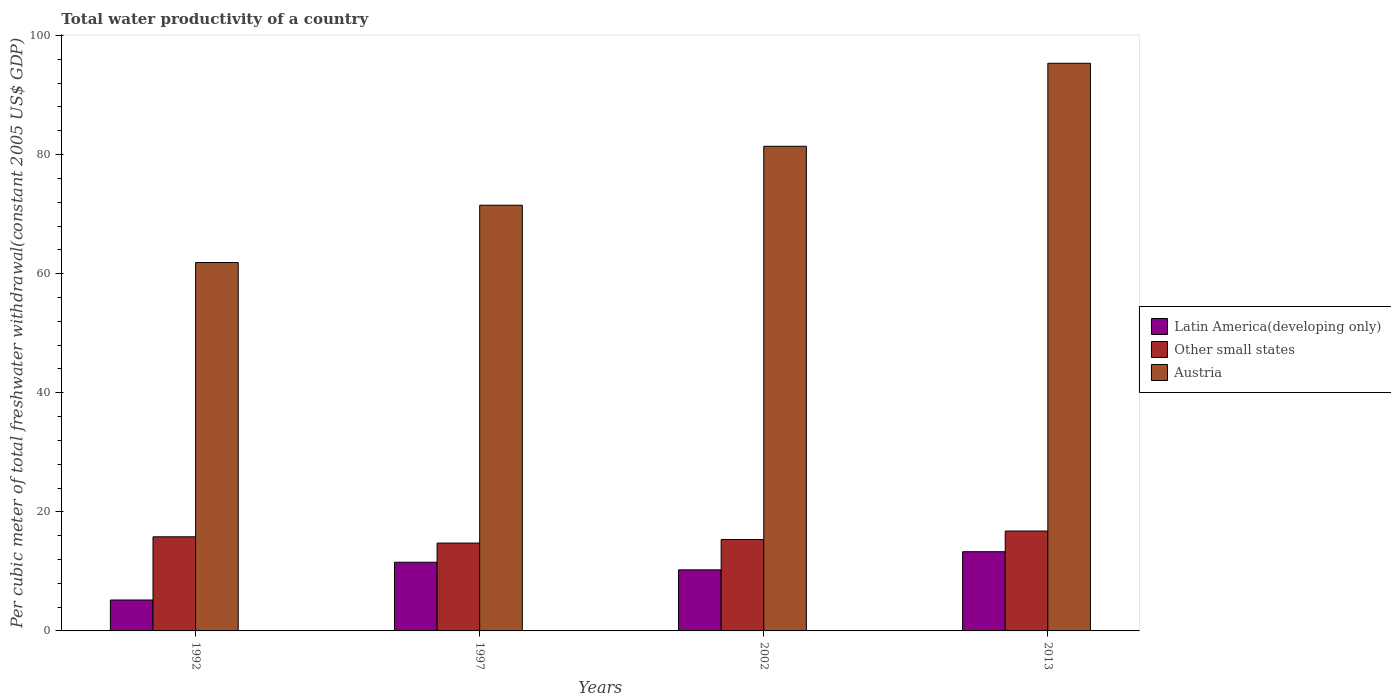How many different coloured bars are there?
Your answer should be very brief. 3. How many groups of bars are there?
Provide a short and direct response. 4. How many bars are there on the 4th tick from the right?
Make the answer very short. 3. What is the label of the 3rd group of bars from the left?
Your answer should be compact. 2002. What is the total water productivity in Austria in 2002?
Provide a short and direct response. 81.4. Across all years, what is the maximum total water productivity in Austria?
Give a very brief answer. 95.35. Across all years, what is the minimum total water productivity in Austria?
Keep it short and to the point. 61.88. In which year was the total water productivity in Austria maximum?
Make the answer very short. 2013. What is the total total water productivity in Austria in the graph?
Make the answer very short. 310.13. What is the difference between the total water productivity in Austria in 2002 and that in 2013?
Give a very brief answer. -13.94. What is the difference between the total water productivity in Latin America(developing only) in 2002 and the total water productivity in Austria in 2013?
Make the answer very short. -85.09. What is the average total water productivity in Other small states per year?
Your answer should be very brief. 15.67. In the year 2002, what is the difference between the total water productivity in Austria and total water productivity in Other small states?
Your answer should be compact. 66.05. In how many years, is the total water productivity in Other small states greater than 32 US$?
Provide a short and direct response. 0. What is the ratio of the total water productivity in Austria in 1997 to that in 2002?
Keep it short and to the point. 0.88. Is the total water productivity in Latin America(developing only) in 1997 less than that in 2002?
Your answer should be compact. No. Is the difference between the total water productivity in Austria in 1997 and 2002 greater than the difference between the total water productivity in Other small states in 1997 and 2002?
Provide a short and direct response. No. What is the difference between the highest and the second highest total water productivity in Other small states?
Your answer should be very brief. 0.97. What is the difference between the highest and the lowest total water productivity in Austria?
Provide a short and direct response. 33.47. Is the sum of the total water productivity in Other small states in 1992 and 1997 greater than the maximum total water productivity in Latin America(developing only) across all years?
Provide a succinct answer. Yes. What does the 2nd bar from the left in 2002 represents?
Your response must be concise. Other small states. What does the 2nd bar from the right in 1992 represents?
Provide a short and direct response. Other small states. Are all the bars in the graph horizontal?
Make the answer very short. No. Where does the legend appear in the graph?
Ensure brevity in your answer.  Center right. How many legend labels are there?
Offer a terse response. 3. What is the title of the graph?
Make the answer very short. Total water productivity of a country. Does "New Caledonia" appear as one of the legend labels in the graph?
Offer a terse response. No. What is the label or title of the X-axis?
Ensure brevity in your answer.  Years. What is the label or title of the Y-axis?
Give a very brief answer. Per cubic meter of total freshwater withdrawal(constant 2005 US$ GDP). What is the Per cubic meter of total freshwater withdrawal(constant 2005 US$ GDP) of Latin America(developing only) in 1992?
Give a very brief answer. 5.19. What is the Per cubic meter of total freshwater withdrawal(constant 2005 US$ GDP) of Other small states in 1992?
Make the answer very short. 15.81. What is the Per cubic meter of total freshwater withdrawal(constant 2005 US$ GDP) in Austria in 1992?
Ensure brevity in your answer.  61.88. What is the Per cubic meter of total freshwater withdrawal(constant 2005 US$ GDP) of Latin America(developing only) in 1997?
Give a very brief answer. 11.53. What is the Per cubic meter of total freshwater withdrawal(constant 2005 US$ GDP) of Other small states in 1997?
Give a very brief answer. 14.76. What is the Per cubic meter of total freshwater withdrawal(constant 2005 US$ GDP) in Austria in 1997?
Your response must be concise. 71.5. What is the Per cubic meter of total freshwater withdrawal(constant 2005 US$ GDP) in Latin America(developing only) in 2002?
Ensure brevity in your answer.  10.26. What is the Per cubic meter of total freshwater withdrawal(constant 2005 US$ GDP) in Other small states in 2002?
Provide a short and direct response. 15.35. What is the Per cubic meter of total freshwater withdrawal(constant 2005 US$ GDP) in Austria in 2002?
Make the answer very short. 81.4. What is the Per cubic meter of total freshwater withdrawal(constant 2005 US$ GDP) in Latin America(developing only) in 2013?
Make the answer very short. 13.31. What is the Per cubic meter of total freshwater withdrawal(constant 2005 US$ GDP) in Other small states in 2013?
Keep it short and to the point. 16.78. What is the Per cubic meter of total freshwater withdrawal(constant 2005 US$ GDP) of Austria in 2013?
Make the answer very short. 95.35. Across all years, what is the maximum Per cubic meter of total freshwater withdrawal(constant 2005 US$ GDP) in Latin America(developing only)?
Keep it short and to the point. 13.31. Across all years, what is the maximum Per cubic meter of total freshwater withdrawal(constant 2005 US$ GDP) of Other small states?
Provide a succinct answer. 16.78. Across all years, what is the maximum Per cubic meter of total freshwater withdrawal(constant 2005 US$ GDP) of Austria?
Offer a terse response. 95.35. Across all years, what is the minimum Per cubic meter of total freshwater withdrawal(constant 2005 US$ GDP) of Latin America(developing only)?
Your answer should be compact. 5.19. Across all years, what is the minimum Per cubic meter of total freshwater withdrawal(constant 2005 US$ GDP) of Other small states?
Your response must be concise. 14.76. Across all years, what is the minimum Per cubic meter of total freshwater withdrawal(constant 2005 US$ GDP) of Austria?
Keep it short and to the point. 61.88. What is the total Per cubic meter of total freshwater withdrawal(constant 2005 US$ GDP) of Latin America(developing only) in the graph?
Provide a succinct answer. 40.29. What is the total Per cubic meter of total freshwater withdrawal(constant 2005 US$ GDP) of Other small states in the graph?
Make the answer very short. 62.69. What is the total Per cubic meter of total freshwater withdrawal(constant 2005 US$ GDP) of Austria in the graph?
Offer a very short reply. 310.13. What is the difference between the Per cubic meter of total freshwater withdrawal(constant 2005 US$ GDP) in Latin America(developing only) in 1992 and that in 1997?
Give a very brief answer. -6.34. What is the difference between the Per cubic meter of total freshwater withdrawal(constant 2005 US$ GDP) of Austria in 1992 and that in 1997?
Provide a short and direct response. -9.63. What is the difference between the Per cubic meter of total freshwater withdrawal(constant 2005 US$ GDP) of Latin America(developing only) in 1992 and that in 2002?
Provide a short and direct response. -5.06. What is the difference between the Per cubic meter of total freshwater withdrawal(constant 2005 US$ GDP) of Other small states in 1992 and that in 2002?
Your response must be concise. 0.46. What is the difference between the Per cubic meter of total freshwater withdrawal(constant 2005 US$ GDP) in Austria in 1992 and that in 2002?
Your response must be concise. -19.52. What is the difference between the Per cubic meter of total freshwater withdrawal(constant 2005 US$ GDP) of Latin America(developing only) in 1992 and that in 2013?
Your answer should be compact. -8.11. What is the difference between the Per cubic meter of total freshwater withdrawal(constant 2005 US$ GDP) in Other small states in 1992 and that in 2013?
Ensure brevity in your answer.  -0.97. What is the difference between the Per cubic meter of total freshwater withdrawal(constant 2005 US$ GDP) in Austria in 1992 and that in 2013?
Make the answer very short. -33.47. What is the difference between the Per cubic meter of total freshwater withdrawal(constant 2005 US$ GDP) of Latin America(developing only) in 1997 and that in 2002?
Give a very brief answer. 1.28. What is the difference between the Per cubic meter of total freshwater withdrawal(constant 2005 US$ GDP) in Other small states in 1997 and that in 2002?
Offer a very short reply. -0.59. What is the difference between the Per cubic meter of total freshwater withdrawal(constant 2005 US$ GDP) of Austria in 1997 and that in 2002?
Your answer should be very brief. -9.9. What is the difference between the Per cubic meter of total freshwater withdrawal(constant 2005 US$ GDP) in Latin America(developing only) in 1997 and that in 2013?
Offer a very short reply. -1.77. What is the difference between the Per cubic meter of total freshwater withdrawal(constant 2005 US$ GDP) in Other small states in 1997 and that in 2013?
Provide a short and direct response. -2.02. What is the difference between the Per cubic meter of total freshwater withdrawal(constant 2005 US$ GDP) in Austria in 1997 and that in 2013?
Provide a succinct answer. -23.84. What is the difference between the Per cubic meter of total freshwater withdrawal(constant 2005 US$ GDP) of Latin America(developing only) in 2002 and that in 2013?
Offer a very short reply. -3.05. What is the difference between the Per cubic meter of total freshwater withdrawal(constant 2005 US$ GDP) in Other small states in 2002 and that in 2013?
Provide a short and direct response. -1.43. What is the difference between the Per cubic meter of total freshwater withdrawal(constant 2005 US$ GDP) in Austria in 2002 and that in 2013?
Provide a short and direct response. -13.94. What is the difference between the Per cubic meter of total freshwater withdrawal(constant 2005 US$ GDP) in Latin America(developing only) in 1992 and the Per cubic meter of total freshwater withdrawal(constant 2005 US$ GDP) in Other small states in 1997?
Offer a terse response. -9.56. What is the difference between the Per cubic meter of total freshwater withdrawal(constant 2005 US$ GDP) of Latin America(developing only) in 1992 and the Per cubic meter of total freshwater withdrawal(constant 2005 US$ GDP) of Austria in 1997?
Make the answer very short. -66.31. What is the difference between the Per cubic meter of total freshwater withdrawal(constant 2005 US$ GDP) of Other small states in 1992 and the Per cubic meter of total freshwater withdrawal(constant 2005 US$ GDP) of Austria in 1997?
Provide a short and direct response. -55.7. What is the difference between the Per cubic meter of total freshwater withdrawal(constant 2005 US$ GDP) of Latin America(developing only) in 1992 and the Per cubic meter of total freshwater withdrawal(constant 2005 US$ GDP) of Other small states in 2002?
Offer a very short reply. -10.15. What is the difference between the Per cubic meter of total freshwater withdrawal(constant 2005 US$ GDP) of Latin America(developing only) in 1992 and the Per cubic meter of total freshwater withdrawal(constant 2005 US$ GDP) of Austria in 2002?
Make the answer very short. -76.21. What is the difference between the Per cubic meter of total freshwater withdrawal(constant 2005 US$ GDP) of Other small states in 1992 and the Per cubic meter of total freshwater withdrawal(constant 2005 US$ GDP) of Austria in 2002?
Ensure brevity in your answer.  -65.6. What is the difference between the Per cubic meter of total freshwater withdrawal(constant 2005 US$ GDP) of Latin America(developing only) in 1992 and the Per cubic meter of total freshwater withdrawal(constant 2005 US$ GDP) of Other small states in 2013?
Offer a very short reply. -11.58. What is the difference between the Per cubic meter of total freshwater withdrawal(constant 2005 US$ GDP) in Latin America(developing only) in 1992 and the Per cubic meter of total freshwater withdrawal(constant 2005 US$ GDP) in Austria in 2013?
Offer a terse response. -90.15. What is the difference between the Per cubic meter of total freshwater withdrawal(constant 2005 US$ GDP) in Other small states in 1992 and the Per cubic meter of total freshwater withdrawal(constant 2005 US$ GDP) in Austria in 2013?
Your answer should be very brief. -79.54. What is the difference between the Per cubic meter of total freshwater withdrawal(constant 2005 US$ GDP) in Latin America(developing only) in 1997 and the Per cubic meter of total freshwater withdrawal(constant 2005 US$ GDP) in Other small states in 2002?
Give a very brief answer. -3.81. What is the difference between the Per cubic meter of total freshwater withdrawal(constant 2005 US$ GDP) in Latin America(developing only) in 1997 and the Per cubic meter of total freshwater withdrawal(constant 2005 US$ GDP) in Austria in 2002?
Your answer should be compact. -69.87. What is the difference between the Per cubic meter of total freshwater withdrawal(constant 2005 US$ GDP) of Other small states in 1997 and the Per cubic meter of total freshwater withdrawal(constant 2005 US$ GDP) of Austria in 2002?
Provide a short and direct response. -66.65. What is the difference between the Per cubic meter of total freshwater withdrawal(constant 2005 US$ GDP) of Latin America(developing only) in 1997 and the Per cubic meter of total freshwater withdrawal(constant 2005 US$ GDP) of Other small states in 2013?
Provide a short and direct response. -5.24. What is the difference between the Per cubic meter of total freshwater withdrawal(constant 2005 US$ GDP) of Latin America(developing only) in 1997 and the Per cubic meter of total freshwater withdrawal(constant 2005 US$ GDP) of Austria in 2013?
Offer a terse response. -83.81. What is the difference between the Per cubic meter of total freshwater withdrawal(constant 2005 US$ GDP) in Other small states in 1997 and the Per cubic meter of total freshwater withdrawal(constant 2005 US$ GDP) in Austria in 2013?
Give a very brief answer. -80.59. What is the difference between the Per cubic meter of total freshwater withdrawal(constant 2005 US$ GDP) of Latin America(developing only) in 2002 and the Per cubic meter of total freshwater withdrawal(constant 2005 US$ GDP) of Other small states in 2013?
Provide a short and direct response. -6.52. What is the difference between the Per cubic meter of total freshwater withdrawal(constant 2005 US$ GDP) of Latin America(developing only) in 2002 and the Per cubic meter of total freshwater withdrawal(constant 2005 US$ GDP) of Austria in 2013?
Your answer should be compact. -85.09. What is the difference between the Per cubic meter of total freshwater withdrawal(constant 2005 US$ GDP) of Other small states in 2002 and the Per cubic meter of total freshwater withdrawal(constant 2005 US$ GDP) of Austria in 2013?
Ensure brevity in your answer.  -80. What is the average Per cubic meter of total freshwater withdrawal(constant 2005 US$ GDP) of Latin America(developing only) per year?
Your response must be concise. 10.07. What is the average Per cubic meter of total freshwater withdrawal(constant 2005 US$ GDP) of Other small states per year?
Offer a terse response. 15.67. What is the average Per cubic meter of total freshwater withdrawal(constant 2005 US$ GDP) of Austria per year?
Keep it short and to the point. 77.53. In the year 1992, what is the difference between the Per cubic meter of total freshwater withdrawal(constant 2005 US$ GDP) of Latin America(developing only) and Per cubic meter of total freshwater withdrawal(constant 2005 US$ GDP) of Other small states?
Provide a succinct answer. -10.61. In the year 1992, what is the difference between the Per cubic meter of total freshwater withdrawal(constant 2005 US$ GDP) of Latin America(developing only) and Per cubic meter of total freshwater withdrawal(constant 2005 US$ GDP) of Austria?
Keep it short and to the point. -56.68. In the year 1992, what is the difference between the Per cubic meter of total freshwater withdrawal(constant 2005 US$ GDP) in Other small states and Per cubic meter of total freshwater withdrawal(constant 2005 US$ GDP) in Austria?
Provide a short and direct response. -46.07. In the year 1997, what is the difference between the Per cubic meter of total freshwater withdrawal(constant 2005 US$ GDP) of Latin America(developing only) and Per cubic meter of total freshwater withdrawal(constant 2005 US$ GDP) of Other small states?
Give a very brief answer. -3.22. In the year 1997, what is the difference between the Per cubic meter of total freshwater withdrawal(constant 2005 US$ GDP) in Latin America(developing only) and Per cubic meter of total freshwater withdrawal(constant 2005 US$ GDP) in Austria?
Ensure brevity in your answer.  -59.97. In the year 1997, what is the difference between the Per cubic meter of total freshwater withdrawal(constant 2005 US$ GDP) of Other small states and Per cubic meter of total freshwater withdrawal(constant 2005 US$ GDP) of Austria?
Make the answer very short. -56.75. In the year 2002, what is the difference between the Per cubic meter of total freshwater withdrawal(constant 2005 US$ GDP) of Latin America(developing only) and Per cubic meter of total freshwater withdrawal(constant 2005 US$ GDP) of Other small states?
Offer a very short reply. -5.09. In the year 2002, what is the difference between the Per cubic meter of total freshwater withdrawal(constant 2005 US$ GDP) of Latin America(developing only) and Per cubic meter of total freshwater withdrawal(constant 2005 US$ GDP) of Austria?
Your answer should be compact. -71.15. In the year 2002, what is the difference between the Per cubic meter of total freshwater withdrawal(constant 2005 US$ GDP) in Other small states and Per cubic meter of total freshwater withdrawal(constant 2005 US$ GDP) in Austria?
Your answer should be very brief. -66.05. In the year 2013, what is the difference between the Per cubic meter of total freshwater withdrawal(constant 2005 US$ GDP) in Latin America(developing only) and Per cubic meter of total freshwater withdrawal(constant 2005 US$ GDP) in Other small states?
Ensure brevity in your answer.  -3.47. In the year 2013, what is the difference between the Per cubic meter of total freshwater withdrawal(constant 2005 US$ GDP) of Latin America(developing only) and Per cubic meter of total freshwater withdrawal(constant 2005 US$ GDP) of Austria?
Your response must be concise. -82.04. In the year 2013, what is the difference between the Per cubic meter of total freshwater withdrawal(constant 2005 US$ GDP) of Other small states and Per cubic meter of total freshwater withdrawal(constant 2005 US$ GDP) of Austria?
Make the answer very short. -78.57. What is the ratio of the Per cubic meter of total freshwater withdrawal(constant 2005 US$ GDP) of Latin America(developing only) in 1992 to that in 1997?
Provide a succinct answer. 0.45. What is the ratio of the Per cubic meter of total freshwater withdrawal(constant 2005 US$ GDP) of Other small states in 1992 to that in 1997?
Make the answer very short. 1.07. What is the ratio of the Per cubic meter of total freshwater withdrawal(constant 2005 US$ GDP) in Austria in 1992 to that in 1997?
Provide a succinct answer. 0.87. What is the ratio of the Per cubic meter of total freshwater withdrawal(constant 2005 US$ GDP) of Latin America(developing only) in 1992 to that in 2002?
Provide a short and direct response. 0.51. What is the ratio of the Per cubic meter of total freshwater withdrawal(constant 2005 US$ GDP) of Other small states in 1992 to that in 2002?
Make the answer very short. 1.03. What is the ratio of the Per cubic meter of total freshwater withdrawal(constant 2005 US$ GDP) of Austria in 1992 to that in 2002?
Make the answer very short. 0.76. What is the ratio of the Per cubic meter of total freshwater withdrawal(constant 2005 US$ GDP) of Latin America(developing only) in 1992 to that in 2013?
Provide a short and direct response. 0.39. What is the ratio of the Per cubic meter of total freshwater withdrawal(constant 2005 US$ GDP) in Other small states in 1992 to that in 2013?
Keep it short and to the point. 0.94. What is the ratio of the Per cubic meter of total freshwater withdrawal(constant 2005 US$ GDP) of Austria in 1992 to that in 2013?
Keep it short and to the point. 0.65. What is the ratio of the Per cubic meter of total freshwater withdrawal(constant 2005 US$ GDP) in Latin America(developing only) in 1997 to that in 2002?
Give a very brief answer. 1.12. What is the ratio of the Per cubic meter of total freshwater withdrawal(constant 2005 US$ GDP) of Other small states in 1997 to that in 2002?
Offer a very short reply. 0.96. What is the ratio of the Per cubic meter of total freshwater withdrawal(constant 2005 US$ GDP) in Austria in 1997 to that in 2002?
Offer a very short reply. 0.88. What is the ratio of the Per cubic meter of total freshwater withdrawal(constant 2005 US$ GDP) in Latin America(developing only) in 1997 to that in 2013?
Offer a terse response. 0.87. What is the ratio of the Per cubic meter of total freshwater withdrawal(constant 2005 US$ GDP) of Other small states in 1997 to that in 2013?
Make the answer very short. 0.88. What is the ratio of the Per cubic meter of total freshwater withdrawal(constant 2005 US$ GDP) in Austria in 1997 to that in 2013?
Provide a succinct answer. 0.75. What is the ratio of the Per cubic meter of total freshwater withdrawal(constant 2005 US$ GDP) in Latin America(developing only) in 2002 to that in 2013?
Your response must be concise. 0.77. What is the ratio of the Per cubic meter of total freshwater withdrawal(constant 2005 US$ GDP) of Other small states in 2002 to that in 2013?
Make the answer very short. 0.91. What is the ratio of the Per cubic meter of total freshwater withdrawal(constant 2005 US$ GDP) in Austria in 2002 to that in 2013?
Keep it short and to the point. 0.85. What is the difference between the highest and the second highest Per cubic meter of total freshwater withdrawal(constant 2005 US$ GDP) of Latin America(developing only)?
Your response must be concise. 1.77. What is the difference between the highest and the second highest Per cubic meter of total freshwater withdrawal(constant 2005 US$ GDP) of Other small states?
Your answer should be very brief. 0.97. What is the difference between the highest and the second highest Per cubic meter of total freshwater withdrawal(constant 2005 US$ GDP) in Austria?
Make the answer very short. 13.94. What is the difference between the highest and the lowest Per cubic meter of total freshwater withdrawal(constant 2005 US$ GDP) in Latin America(developing only)?
Offer a very short reply. 8.11. What is the difference between the highest and the lowest Per cubic meter of total freshwater withdrawal(constant 2005 US$ GDP) in Other small states?
Give a very brief answer. 2.02. What is the difference between the highest and the lowest Per cubic meter of total freshwater withdrawal(constant 2005 US$ GDP) of Austria?
Your answer should be very brief. 33.47. 